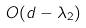<formula> <loc_0><loc_0><loc_500><loc_500>O ( d - \lambda _ { 2 } )</formula> 